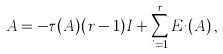Convert formula to latex. <formula><loc_0><loc_0><loc_500><loc_500>A = - \tau ( A ) ( r - 1 ) I + \sum _ { i = 1 } ^ { r } E _ { i } ( A ) \, ,</formula> 